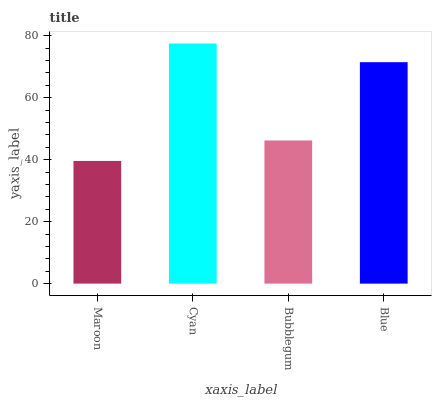Is Maroon the minimum?
Answer yes or no. Yes. Is Cyan the maximum?
Answer yes or no. Yes. Is Bubblegum the minimum?
Answer yes or no. No. Is Bubblegum the maximum?
Answer yes or no. No. Is Cyan greater than Bubblegum?
Answer yes or no. Yes. Is Bubblegum less than Cyan?
Answer yes or no. Yes. Is Bubblegum greater than Cyan?
Answer yes or no. No. Is Cyan less than Bubblegum?
Answer yes or no. No. Is Blue the high median?
Answer yes or no. Yes. Is Bubblegum the low median?
Answer yes or no. Yes. Is Cyan the high median?
Answer yes or no. No. Is Blue the low median?
Answer yes or no. No. 